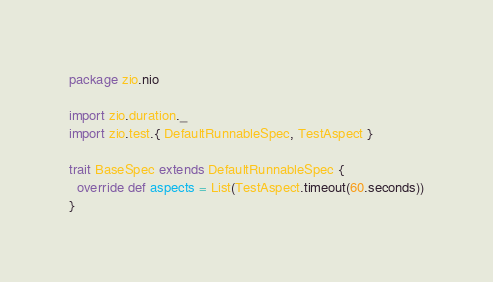Convert code to text. <code><loc_0><loc_0><loc_500><loc_500><_Scala_>package zio.nio

import zio.duration._
import zio.test.{ DefaultRunnableSpec, TestAspect }

trait BaseSpec extends DefaultRunnableSpec {
  override def aspects = List(TestAspect.timeout(60.seconds))
}
</code> 